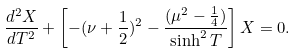Convert formula to latex. <formula><loc_0><loc_0><loc_500><loc_500>\frac { d ^ { 2 } X } { d T ^ { 2 } } + \left [ - ( \nu + \frac { 1 } { 2 } ) ^ { 2 } - \frac { ( \mu ^ { 2 } - \frac { 1 } { 4 } ) } { \sinh ^ { 2 } T } \right ] X = 0 .</formula> 